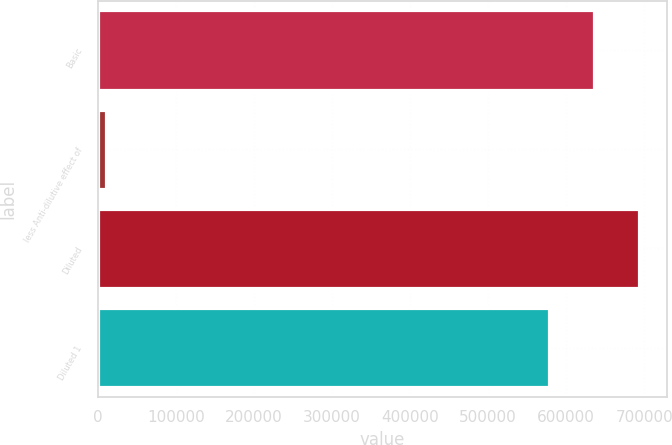Convert chart. <chart><loc_0><loc_0><loc_500><loc_500><bar_chart><fcel>Basic<fcel>less Anti-dilutive effect of<fcel>Diluted<fcel>Diluted 1<nl><fcel>636180<fcel>10566<fcel>693773<fcel>578588<nl></chart> 